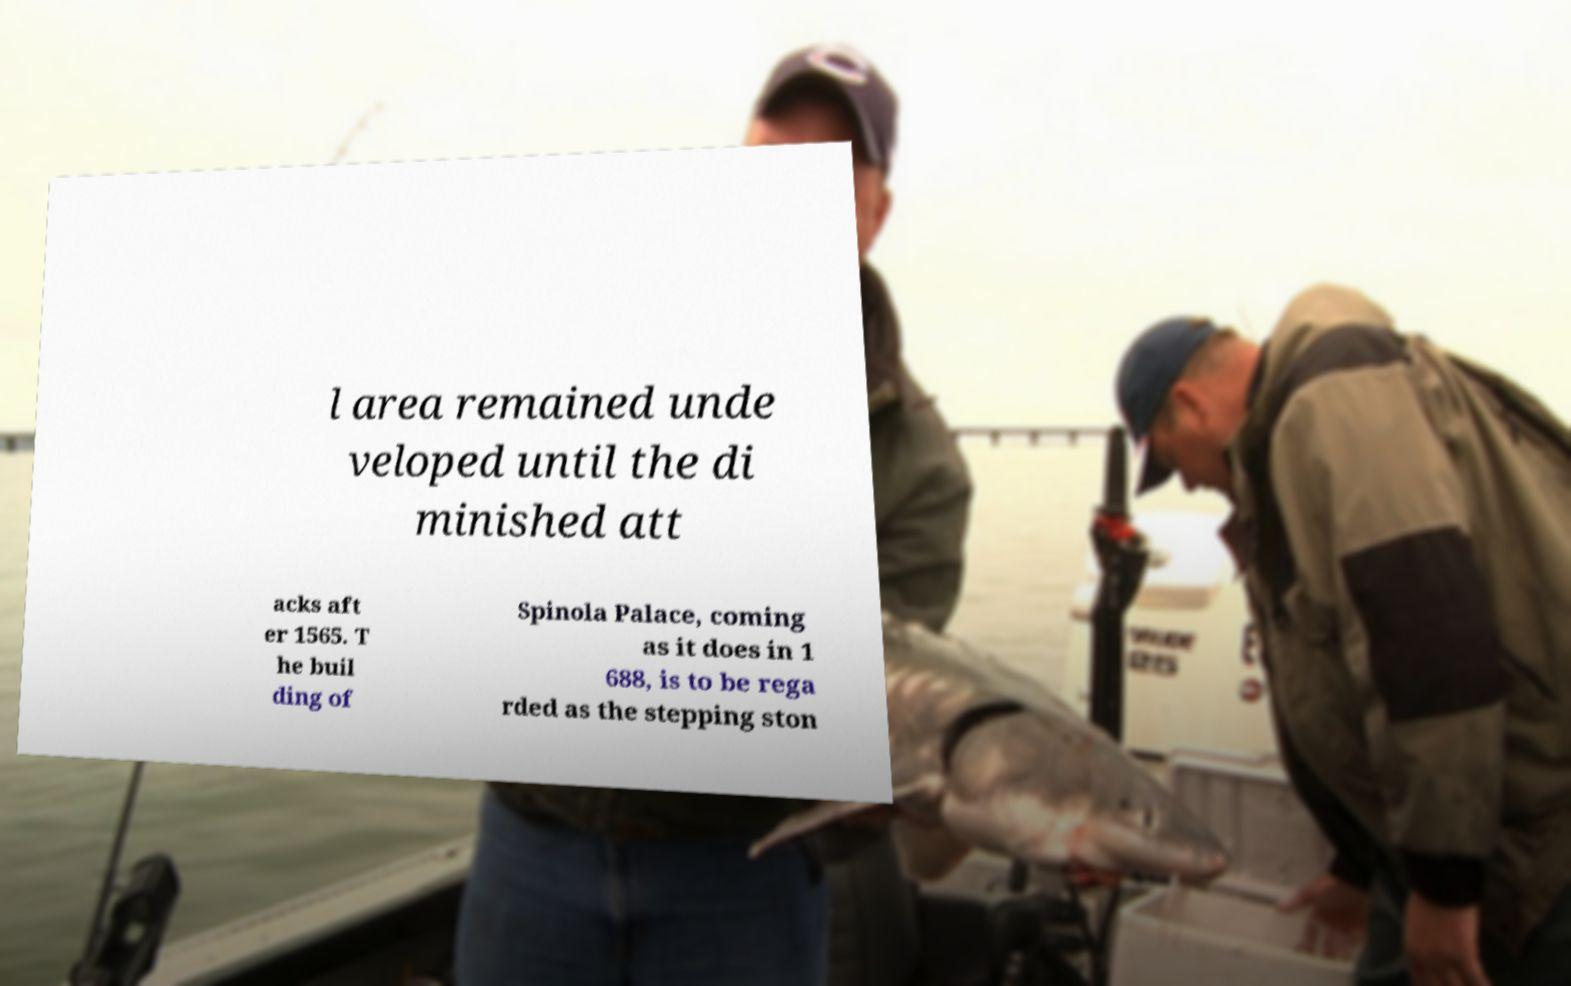There's text embedded in this image that I need extracted. Can you transcribe it verbatim? l area remained unde veloped until the di minished att acks aft er 1565. T he buil ding of Spinola Palace, coming as it does in 1 688, is to be rega rded as the stepping ston 